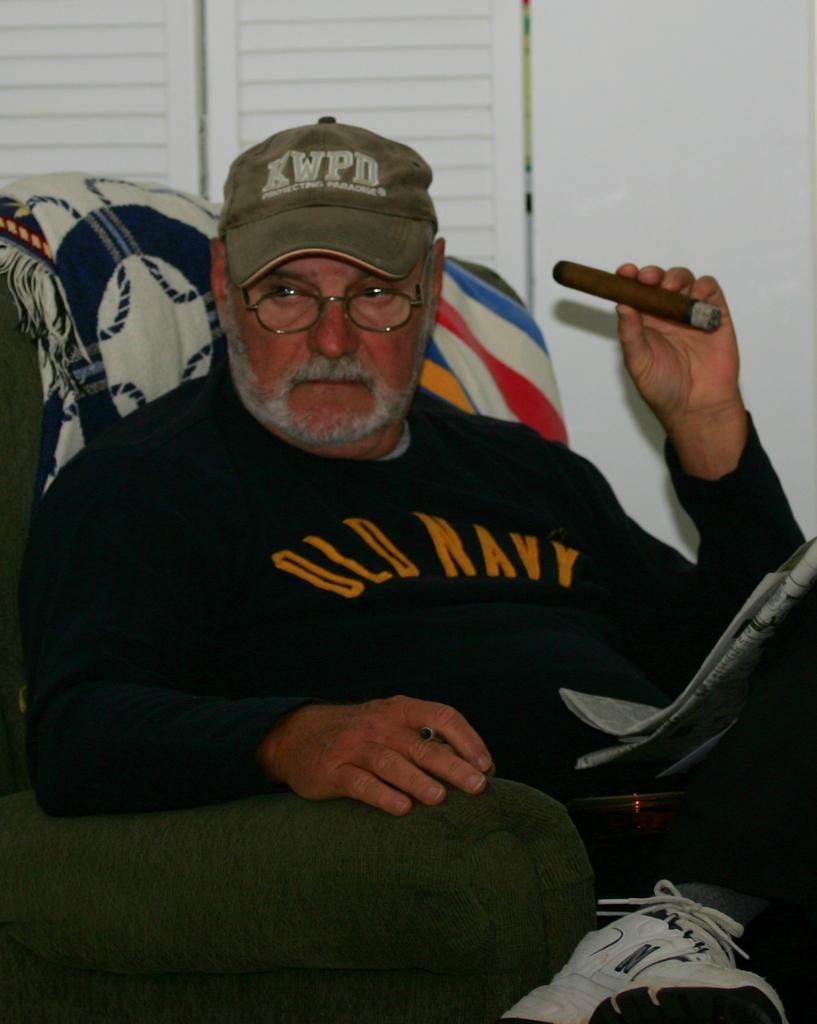What is written on his sweatshirt?
Offer a very short reply. Old navy. What is the abbreviation on his hat?
Make the answer very short. Kwpd. 